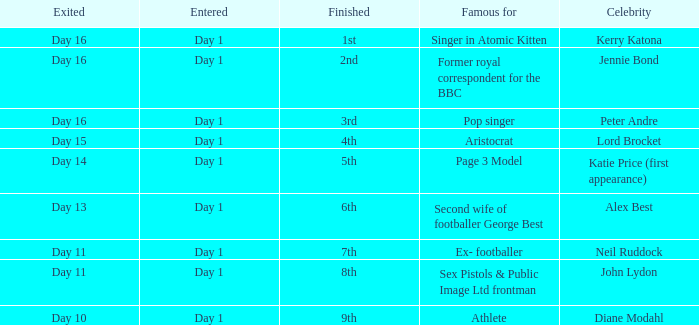Name the number of celebrity for athlete 1.0. 